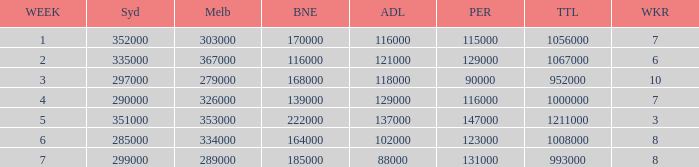How many viewers were there in Sydney for the episode when there were 334000 in Melbourne? 285000.0. 